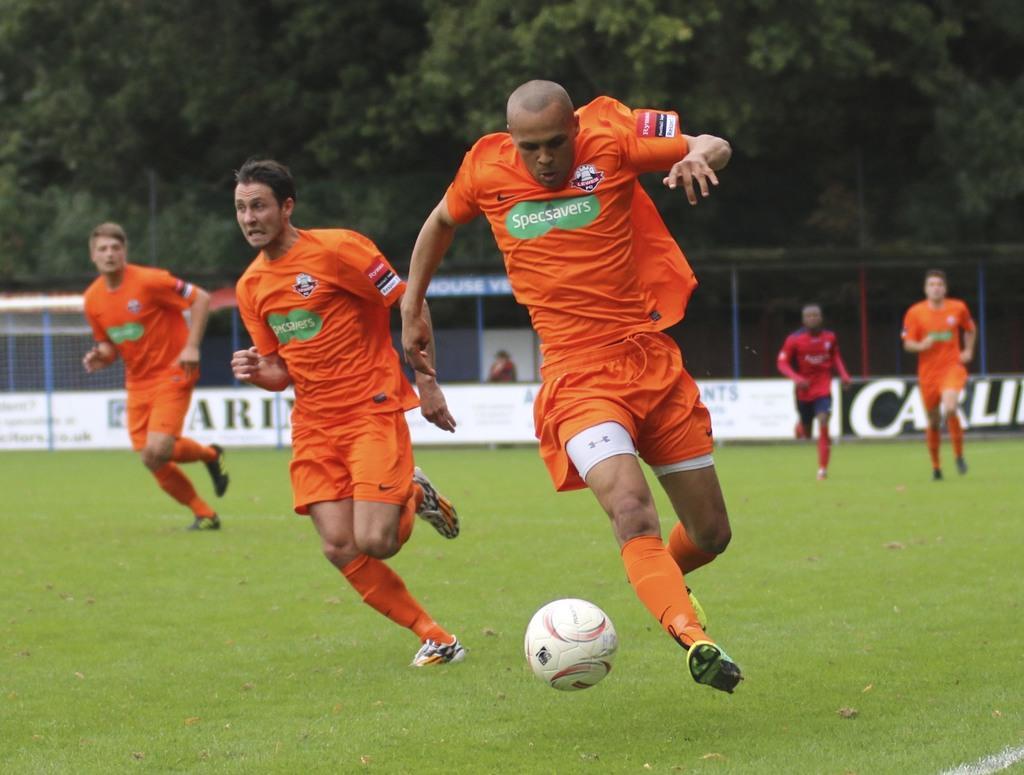Can you describe this image briefly? In the image we can see there are people running. They are wearing clothes, socks and shoes. Here we can see a ball, grass, net, fence, posts and trees. 